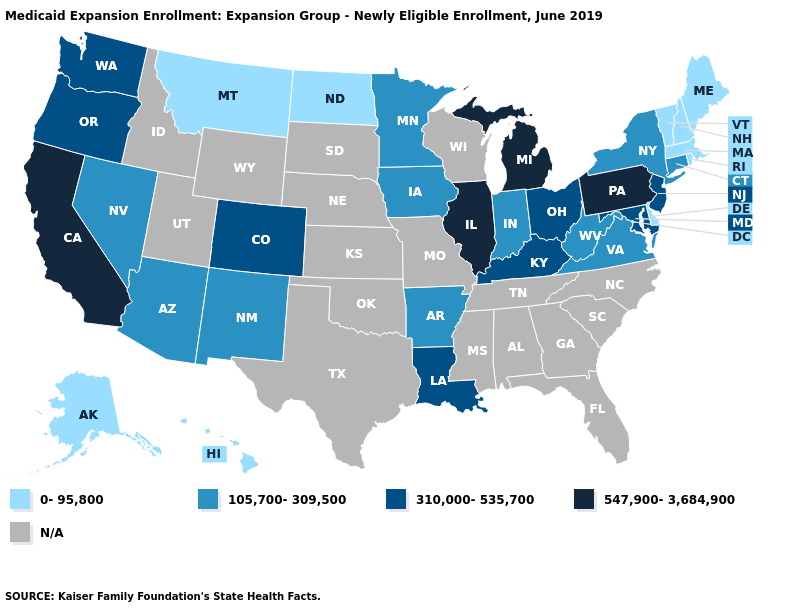What is the value of Indiana?
Be succinct. 105,700-309,500. What is the value of New York?
Be succinct. 105,700-309,500. Does Hawaii have the lowest value in the USA?
Write a very short answer. Yes. What is the value of Illinois?
Quick response, please. 547,900-3,684,900. Name the states that have a value in the range N/A?
Quick response, please. Alabama, Florida, Georgia, Idaho, Kansas, Mississippi, Missouri, Nebraska, North Carolina, Oklahoma, South Carolina, South Dakota, Tennessee, Texas, Utah, Wisconsin, Wyoming. What is the highest value in states that border New Mexico?
Short answer required. 310,000-535,700. What is the value of Pennsylvania?
Quick response, please. 547,900-3,684,900. What is the value of Pennsylvania?
Short answer required. 547,900-3,684,900. Does Oregon have the lowest value in the West?
Be succinct. No. What is the value of Massachusetts?
Give a very brief answer. 0-95,800. What is the value of New Jersey?
Concise answer only. 310,000-535,700. Does California have the highest value in the West?
Be succinct. Yes. Name the states that have a value in the range 310,000-535,700?
Concise answer only. Colorado, Kentucky, Louisiana, Maryland, New Jersey, Ohio, Oregon, Washington. What is the value of Minnesota?
Keep it brief. 105,700-309,500. 